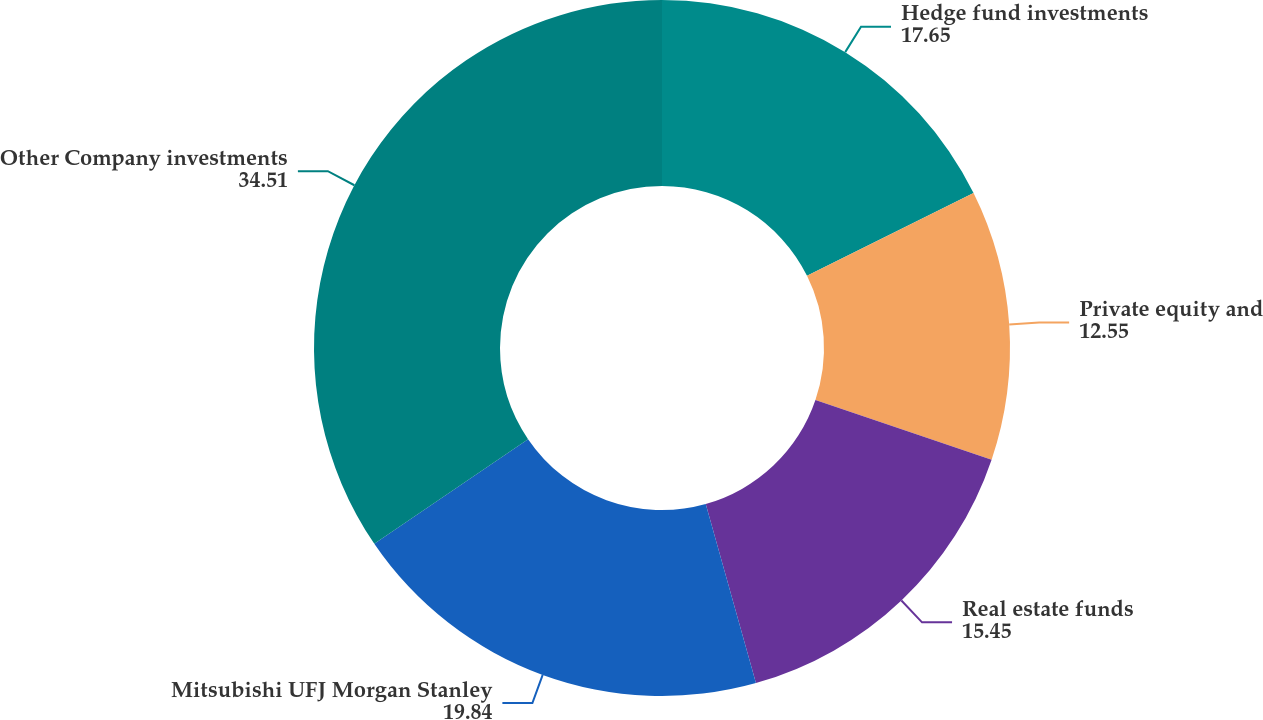Convert chart to OTSL. <chart><loc_0><loc_0><loc_500><loc_500><pie_chart><fcel>Hedge fund investments<fcel>Private equity and<fcel>Real estate funds<fcel>Mitsubishi UFJ Morgan Stanley<fcel>Other Company investments<nl><fcel>17.65%<fcel>12.55%<fcel>15.45%<fcel>19.84%<fcel>34.51%<nl></chart> 